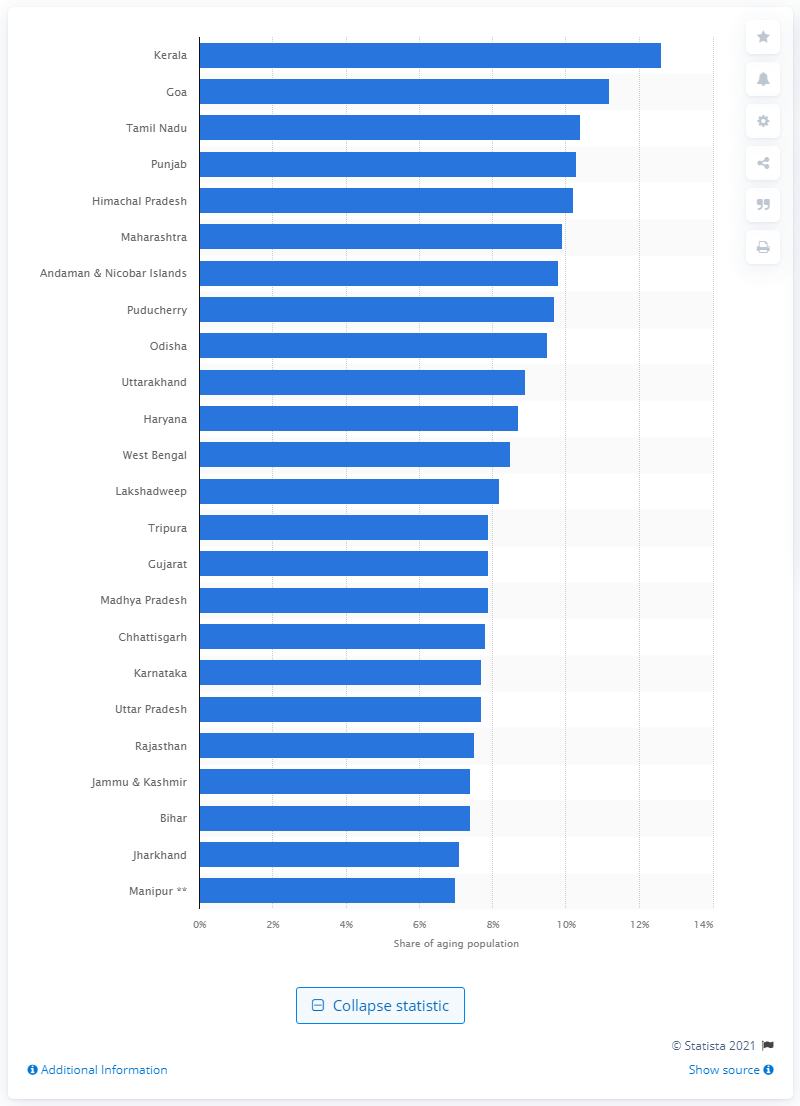Point out several critical features in this image. In 2011, Kerala had the highest percentage of elderly people among all the states in India. In 2011, the age structure of the population in Goa was approximately 11.2% of the population was under the age of 10, 28.4% was between the ages of 10 and 19, 53.4% was between the ages of 20 and 64, and 7.8% was over the age of 65. 